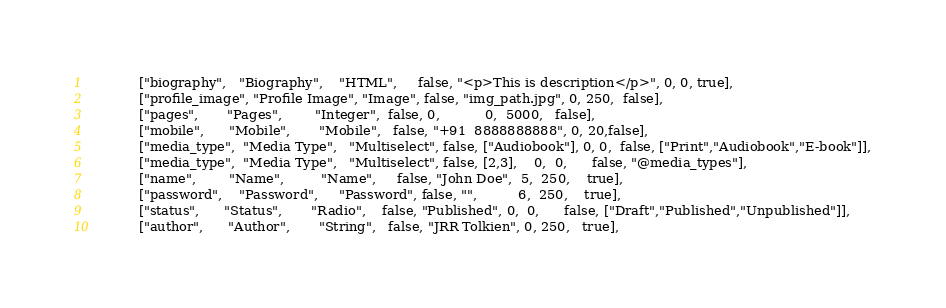<code> <loc_0><loc_0><loc_500><loc_500><_PHP_>            ["biography",   "Biography",    "HTML",     false, "<p>This is description</p>", 0, 0, true],
            ["profile_image", "Profile Image", "Image", false, "img_path.jpg", 0, 250,  false],
            ["pages",       "Pages",        "Integer",  false, 0,           0,  5000,   false],
            ["mobile",      "Mobile",       "Mobile",   false, "+91  8888888888", 0, 20,false],
            ["media_type",  "Media Type",   "Multiselect", false, ["Audiobook"], 0, 0,  false, ["Print","Audiobook","E-book"]],
            ["media_type",  "Media Type",   "Multiselect", false, [2,3],    0,  0,      false, "@media_types"],
            ["name",        "Name",         "Name",     false, "John Doe",  5,  250,    true],
            ["password",    "Password",     "Password", false, "",          6,  250,    true],
            ["status",      "Status",       "Radio",    false, "Published", 0,  0,      false, ["Draft","Published","Unpublished"]],
            ["author",      "Author",       "String",   false, "JRR Tolkien", 0, 250,   true],</code> 